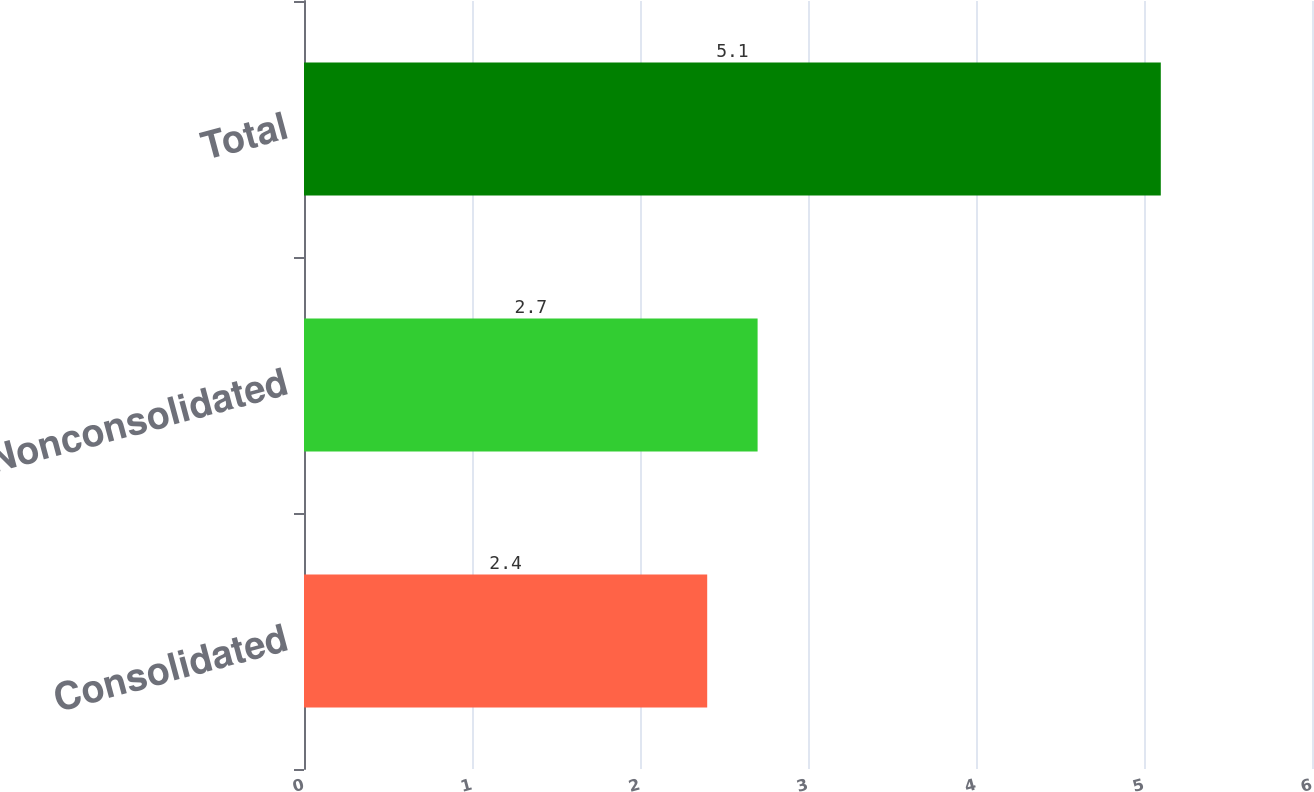Convert chart. <chart><loc_0><loc_0><loc_500><loc_500><bar_chart><fcel>Consolidated<fcel>Nonconsolidated<fcel>Total<nl><fcel>2.4<fcel>2.7<fcel>5.1<nl></chart> 